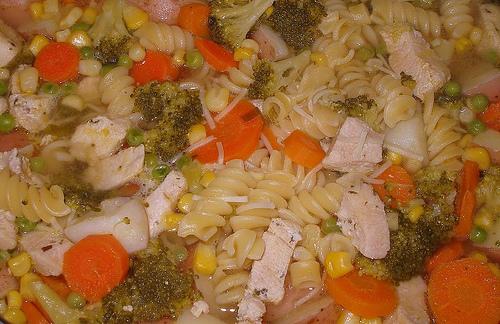What are they having for dinner?
Write a very short answer. Chicken pasta. Are there any purple colored vegetables in the dish?
Concise answer only. No. What colors are in the picture?
Quick response, please. White, yellow, orange and green. Where are the carrots?
Short answer required. In soup. What is the color of the salad?
Short answer required. Orange green and white. Are mushrooms part of this dish?
Give a very brief answer. No. Have these vegetables been cooked?
Short answer required. Yes. What kind of pasta noodle is in this picture?
Give a very brief answer. Spiral. Does the corn still have its husk on it?
Answer briefly. No. What are the orange slices?
Concise answer only. Carrots. Is this a rice dish?
Be succinct. No. Is this food?
Concise answer only. Yes. 